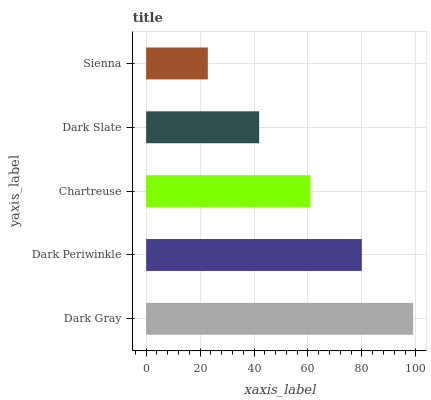Is Sienna the minimum?
Answer yes or no. Yes. Is Dark Gray the maximum?
Answer yes or no. Yes. Is Dark Periwinkle the minimum?
Answer yes or no. No. Is Dark Periwinkle the maximum?
Answer yes or no. No. Is Dark Gray greater than Dark Periwinkle?
Answer yes or no. Yes. Is Dark Periwinkle less than Dark Gray?
Answer yes or no. Yes. Is Dark Periwinkle greater than Dark Gray?
Answer yes or no. No. Is Dark Gray less than Dark Periwinkle?
Answer yes or no. No. Is Chartreuse the high median?
Answer yes or no. Yes. Is Chartreuse the low median?
Answer yes or no. Yes. Is Dark Slate the high median?
Answer yes or no. No. Is Sienna the low median?
Answer yes or no. No. 